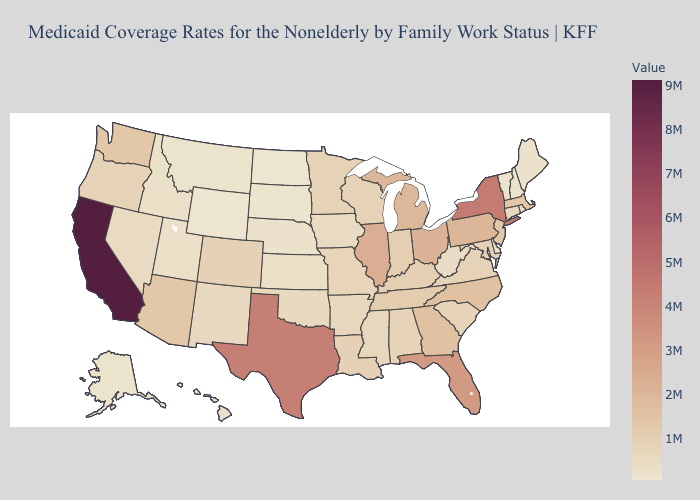Does the map have missing data?
Answer briefly. No. Does Wyoming have the lowest value in the West?
Short answer required. Yes. Among the states that border Tennessee , does Kentucky have the highest value?
Answer briefly. No. Which states have the highest value in the USA?
Short answer required. California. 